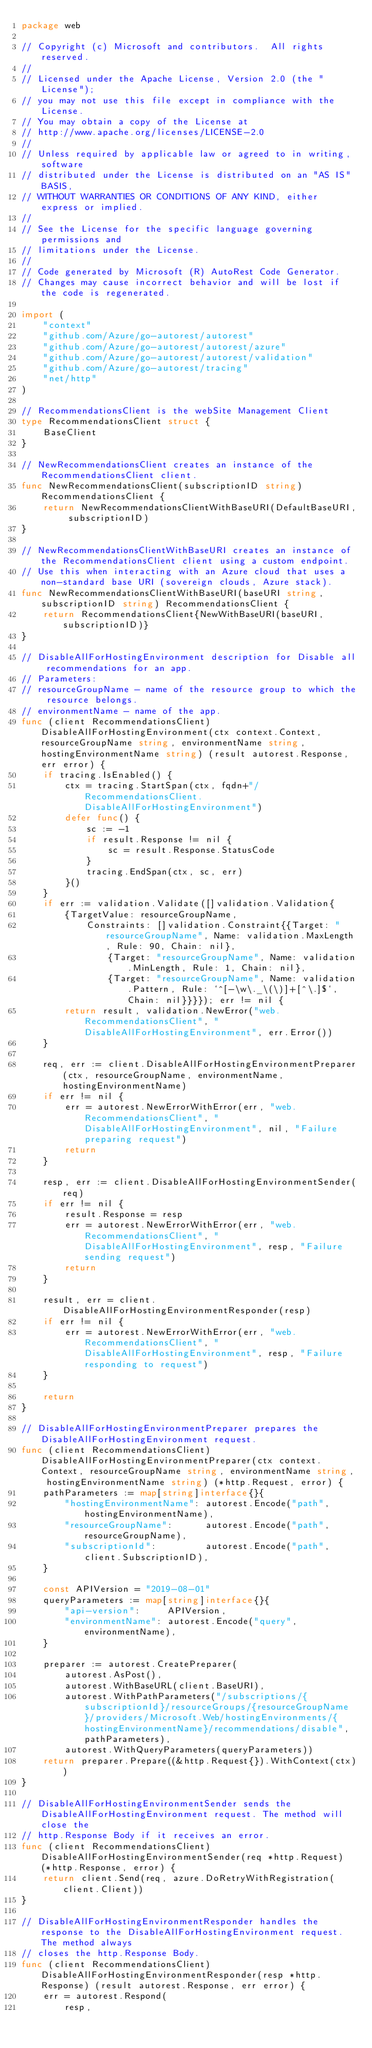Convert code to text. <code><loc_0><loc_0><loc_500><loc_500><_Go_>package web

// Copyright (c) Microsoft and contributors.  All rights reserved.
//
// Licensed under the Apache License, Version 2.0 (the "License");
// you may not use this file except in compliance with the License.
// You may obtain a copy of the License at
// http://www.apache.org/licenses/LICENSE-2.0
//
// Unless required by applicable law or agreed to in writing, software
// distributed under the License is distributed on an "AS IS" BASIS,
// WITHOUT WARRANTIES OR CONDITIONS OF ANY KIND, either express or implied.
//
// See the License for the specific language governing permissions and
// limitations under the License.
//
// Code generated by Microsoft (R) AutoRest Code Generator.
// Changes may cause incorrect behavior and will be lost if the code is regenerated.

import (
	"context"
	"github.com/Azure/go-autorest/autorest"
	"github.com/Azure/go-autorest/autorest/azure"
	"github.com/Azure/go-autorest/autorest/validation"
	"github.com/Azure/go-autorest/tracing"
	"net/http"
)

// RecommendationsClient is the webSite Management Client
type RecommendationsClient struct {
	BaseClient
}

// NewRecommendationsClient creates an instance of the RecommendationsClient client.
func NewRecommendationsClient(subscriptionID string) RecommendationsClient {
	return NewRecommendationsClientWithBaseURI(DefaultBaseURI, subscriptionID)
}

// NewRecommendationsClientWithBaseURI creates an instance of the RecommendationsClient client using a custom endpoint.
// Use this when interacting with an Azure cloud that uses a non-standard base URI (sovereign clouds, Azure stack).
func NewRecommendationsClientWithBaseURI(baseURI string, subscriptionID string) RecommendationsClient {
	return RecommendationsClient{NewWithBaseURI(baseURI, subscriptionID)}
}

// DisableAllForHostingEnvironment description for Disable all recommendations for an app.
// Parameters:
// resourceGroupName - name of the resource group to which the resource belongs.
// environmentName - name of the app.
func (client RecommendationsClient) DisableAllForHostingEnvironment(ctx context.Context, resourceGroupName string, environmentName string, hostingEnvironmentName string) (result autorest.Response, err error) {
	if tracing.IsEnabled() {
		ctx = tracing.StartSpan(ctx, fqdn+"/RecommendationsClient.DisableAllForHostingEnvironment")
		defer func() {
			sc := -1
			if result.Response != nil {
				sc = result.Response.StatusCode
			}
			tracing.EndSpan(ctx, sc, err)
		}()
	}
	if err := validation.Validate([]validation.Validation{
		{TargetValue: resourceGroupName,
			Constraints: []validation.Constraint{{Target: "resourceGroupName", Name: validation.MaxLength, Rule: 90, Chain: nil},
				{Target: "resourceGroupName", Name: validation.MinLength, Rule: 1, Chain: nil},
				{Target: "resourceGroupName", Name: validation.Pattern, Rule: `^[-\w\._\(\)]+[^\.]$`, Chain: nil}}}}); err != nil {
		return result, validation.NewError("web.RecommendationsClient", "DisableAllForHostingEnvironment", err.Error())
	}

	req, err := client.DisableAllForHostingEnvironmentPreparer(ctx, resourceGroupName, environmentName, hostingEnvironmentName)
	if err != nil {
		err = autorest.NewErrorWithError(err, "web.RecommendationsClient", "DisableAllForHostingEnvironment", nil, "Failure preparing request")
		return
	}

	resp, err := client.DisableAllForHostingEnvironmentSender(req)
	if err != nil {
		result.Response = resp
		err = autorest.NewErrorWithError(err, "web.RecommendationsClient", "DisableAllForHostingEnvironment", resp, "Failure sending request")
		return
	}

	result, err = client.DisableAllForHostingEnvironmentResponder(resp)
	if err != nil {
		err = autorest.NewErrorWithError(err, "web.RecommendationsClient", "DisableAllForHostingEnvironment", resp, "Failure responding to request")
	}

	return
}

// DisableAllForHostingEnvironmentPreparer prepares the DisableAllForHostingEnvironment request.
func (client RecommendationsClient) DisableAllForHostingEnvironmentPreparer(ctx context.Context, resourceGroupName string, environmentName string, hostingEnvironmentName string) (*http.Request, error) {
	pathParameters := map[string]interface{}{
		"hostingEnvironmentName": autorest.Encode("path", hostingEnvironmentName),
		"resourceGroupName":      autorest.Encode("path", resourceGroupName),
		"subscriptionId":         autorest.Encode("path", client.SubscriptionID),
	}

	const APIVersion = "2019-08-01"
	queryParameters := map[string]interface{}{
		"api-version":     APIVersion,
		"environmentName": autorest.Encode("query", environmentName),
	}

	preparer := autorest.CreatePreparer(
		autorest.AsPost(),
		autorest.WithBaseURL(client.BaseURI),
		autorest.WithPathParameters("/subscriptions/{subscriptionId}/resourceGroups/{resourceGroupName}/providers/Microsoft.Web/hostingEnvironments/{hostingEnvironmentName}/recommendations/disable", pathParameters),
		autorest.WithQueryParameters(queryParameters))
	return preparer.Prepare((&http.Request{}).WithContext(ctx))
}

// DisableAllForHostingEnvironmentSender sends the DisableAllForHostingEnvironment request. The method will close the
// http.Response Body if it receives an error.
func (client RecommendationsClient) DisableAllForHostingEnvironmentSender(req *http.Request) (*http.Response, error) {
	return client.Send(req, azure.DoRetryWithRegistration(client.Client))
}

// DisableAllForHostingEnvironmentResponder handles the response to the DisableAllForHostingEnvironment request. The method always
// closes the http.Response Body.
func (client RecommendationsClient) DisableAllForHostingEnvironmentResponder(resp *http.Response) (result autorest.Response, err error) {
	err = autorest.Respond(
		resp,</code> 